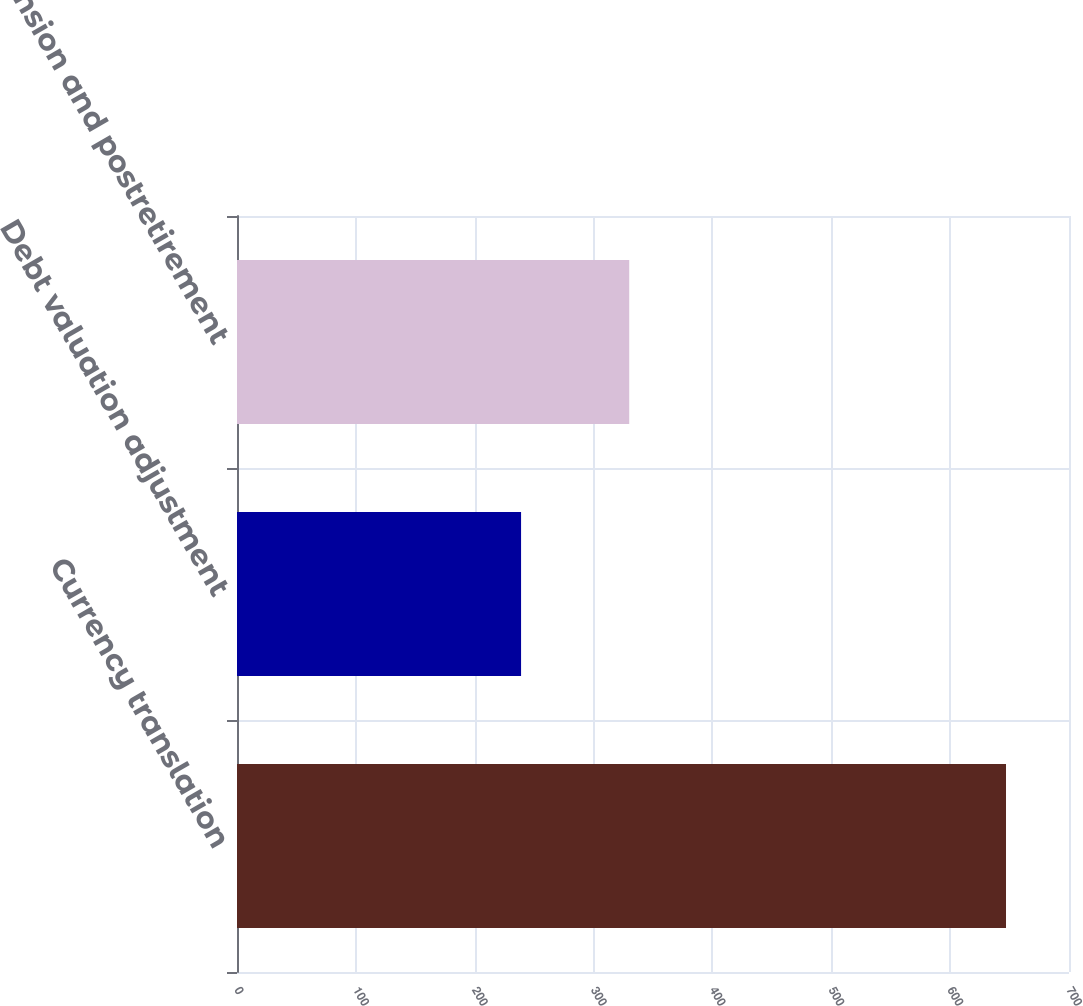<chart> <loc_0><loc_0><loc_500><loc_500><bar_chart><fcel>Currency translation<fcel>Debt valuation adjustment<fcel>Pension and postretirement<nl><fcel>647<fcel>239<fcel>330<nl></chart> 